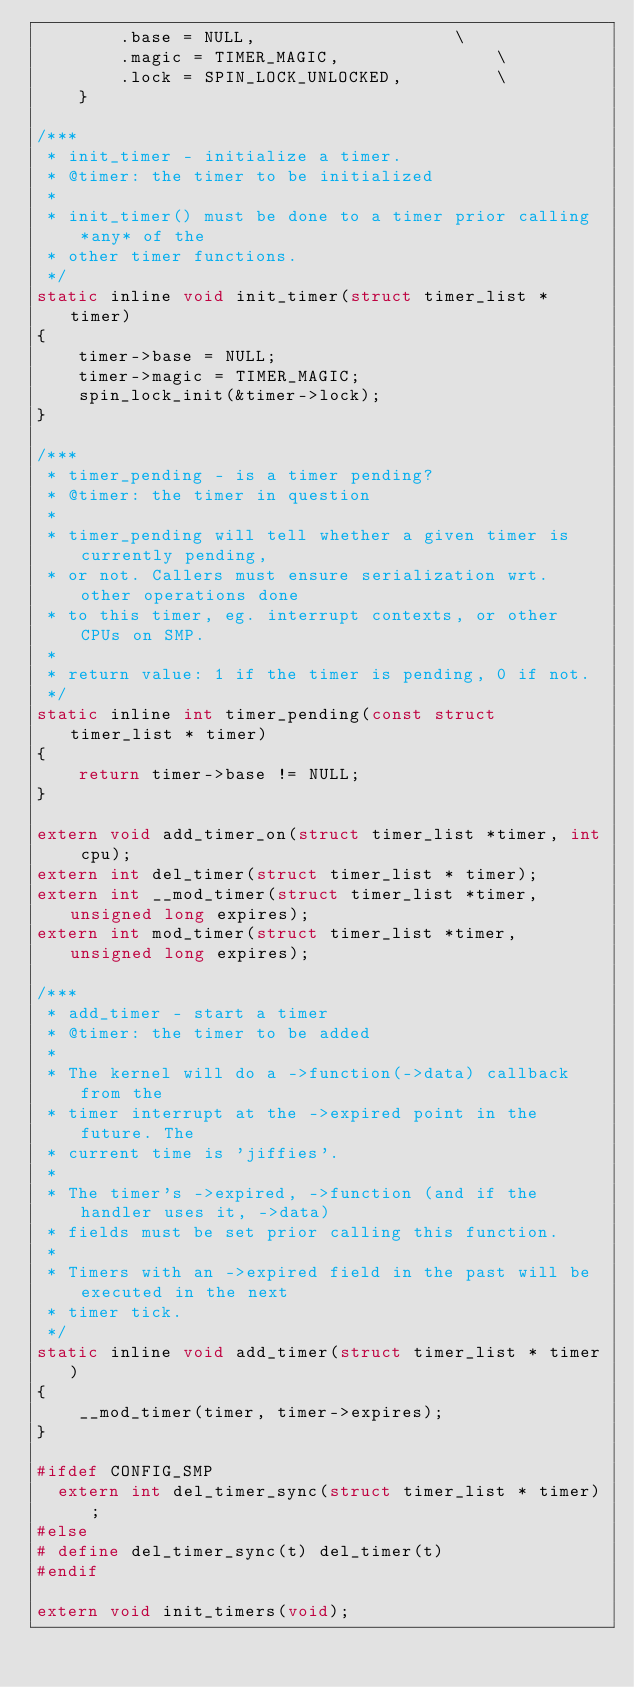Convert code to text. <code><loc_0><loc_0><loc_500><loc_500><_C_>		.base = NULL,					\
		.magic = TIMER_MAGIC,				\
		.lock = SPIN_LOCK_UNLOCKED,			\
	}

/***
 * init_timer - initialize a timer.
 * @timer: the timer to be initialized
 *
 * init_timer() must be done to a timer prior calling *any* of the
 * other timer functions.
 */
static inline void init_timer(struct timer_list * timer)
{
	timer->base = NULL;
	timer->magic = TIMER_MAGIC;
	spin_lock_init(&timer->lock);
}

/***
 * timer_pending - is a timer pending?
 * @timer: the timer in question
 *
 * timer_pending will tell whether a given timer is currently pending,
 * or not. Callers must ensure serialization wrt. other operations done
 * to this timer, eg. interrupt contexts, or other CPUs on SMP.
 *
 * return value: 1 if the timer is pending, 0 if not.
 */
static inline int timer_pending(const struct timer_list * timer)
{
	return timer->base != NULL;
}

extern void add_timer_on(struct timer_list *timer, int cpu);
extern int del_timer(struct timer_list * timer);
extern int __mod_timer(struct timer_list *timer, unsigned long expires);
extern int mod_timer(struct timer_list *timer, unsigned long expires);

/***
 * add_timer - start a timer
 * @timer: the timer to be added
 *
 * The kernel will do a ->function(->data) callback from the
 * timer interrupt at the ->expired point in the future. The
 * current time is 'jiffies'.
 *
 * The timer's ->expired, ->function (and if the handler uses it, ->data)
 * fields must be set prior calling this function.
 *
 * Timers with an ->expired field in the past will be executed in the next
 * timer tick.
 */
static inline void add_timer(struct timer_list * timer)
{
	__mod_timer(timer, timer->expires);
}

#ifdef CONFIG_SMP
  extern int del_timer_sync(struct timer_list * timer);
#else
# define del_timer_sync(t) del_timer(t)
#endif

extern void init_timers(void);</code> 